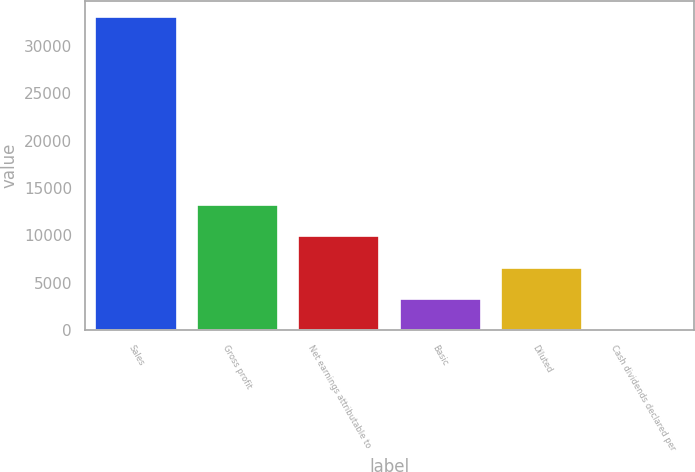<chart> <loc_0><loc_0><loc_500><loc_500><bar_chart><fcel>Sales<fcel>Gross profit<fcel>Net earnings attributable to<fcel>Basic<fcel>Diluted<fcel>Cash dividends declared per<nl><fcel>33021<fcel>13208.6<fcel>9906.58<fcel>3302.46<fcel>6604.52<fcel>0.4<nl></chart> 